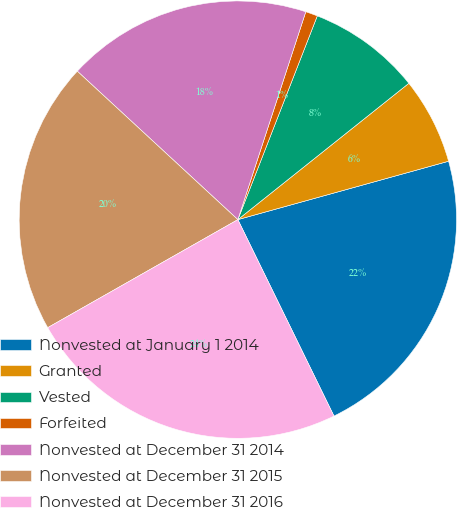Convert chart. <chart><loc_0><loc_0><loc_500><loc_500><pie_chart><fcel>Nonvested at January 1 2014<fcel>Granted<fcel>Vested<fcel>Forfeited<fcel>Nonvested at December 31 2014<fcel>Nonvested at December 31 2015<fcel>Nonvested at December 31 2016<nl><fcel>22.06%<fcel>6.41%<fcel>8.37%<fcel>0.89%<fcel>18.15%<fcel>20.1%<fcel>24.02%<nl></chart> 